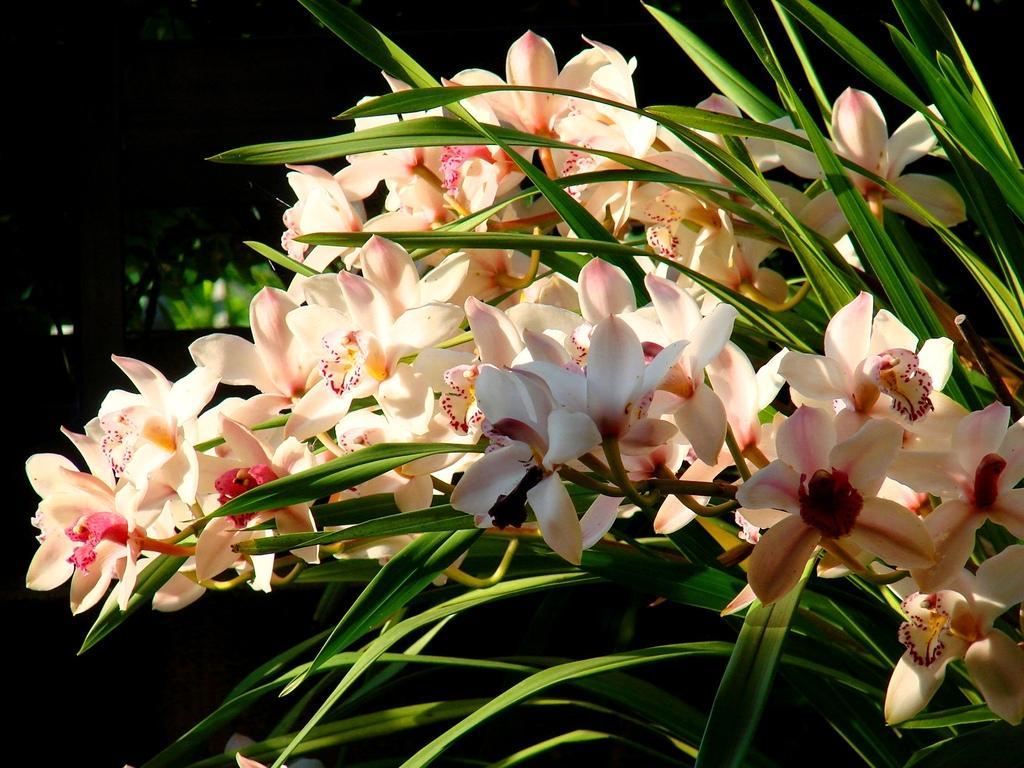Please provide a concise description of this image. In this picture white flowers and plants. The background of the image is dark. 